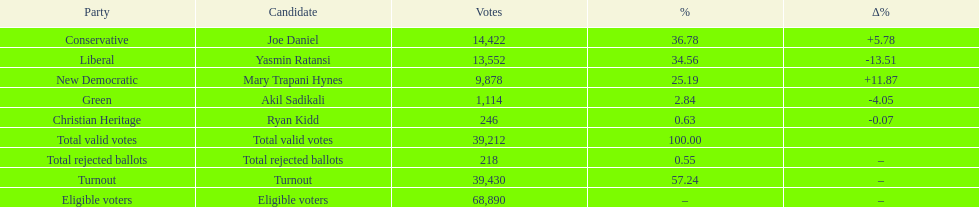Which contender received the highest number of votes? Joe Daniel. 